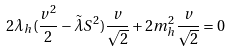<formula> <loc_0><loc_0><loc_500><loc_500>2 \lambda _ { h } ( \frac { v ^ { 2 } } { 2 } - \tilde { \lambda } S ^ { 2 } ) \frac { v } { \sqrt { 2 } } + 2 m ^ { 2 } _ { h } \frac { v } { \sqrt { 2 } } = 0</formula> 